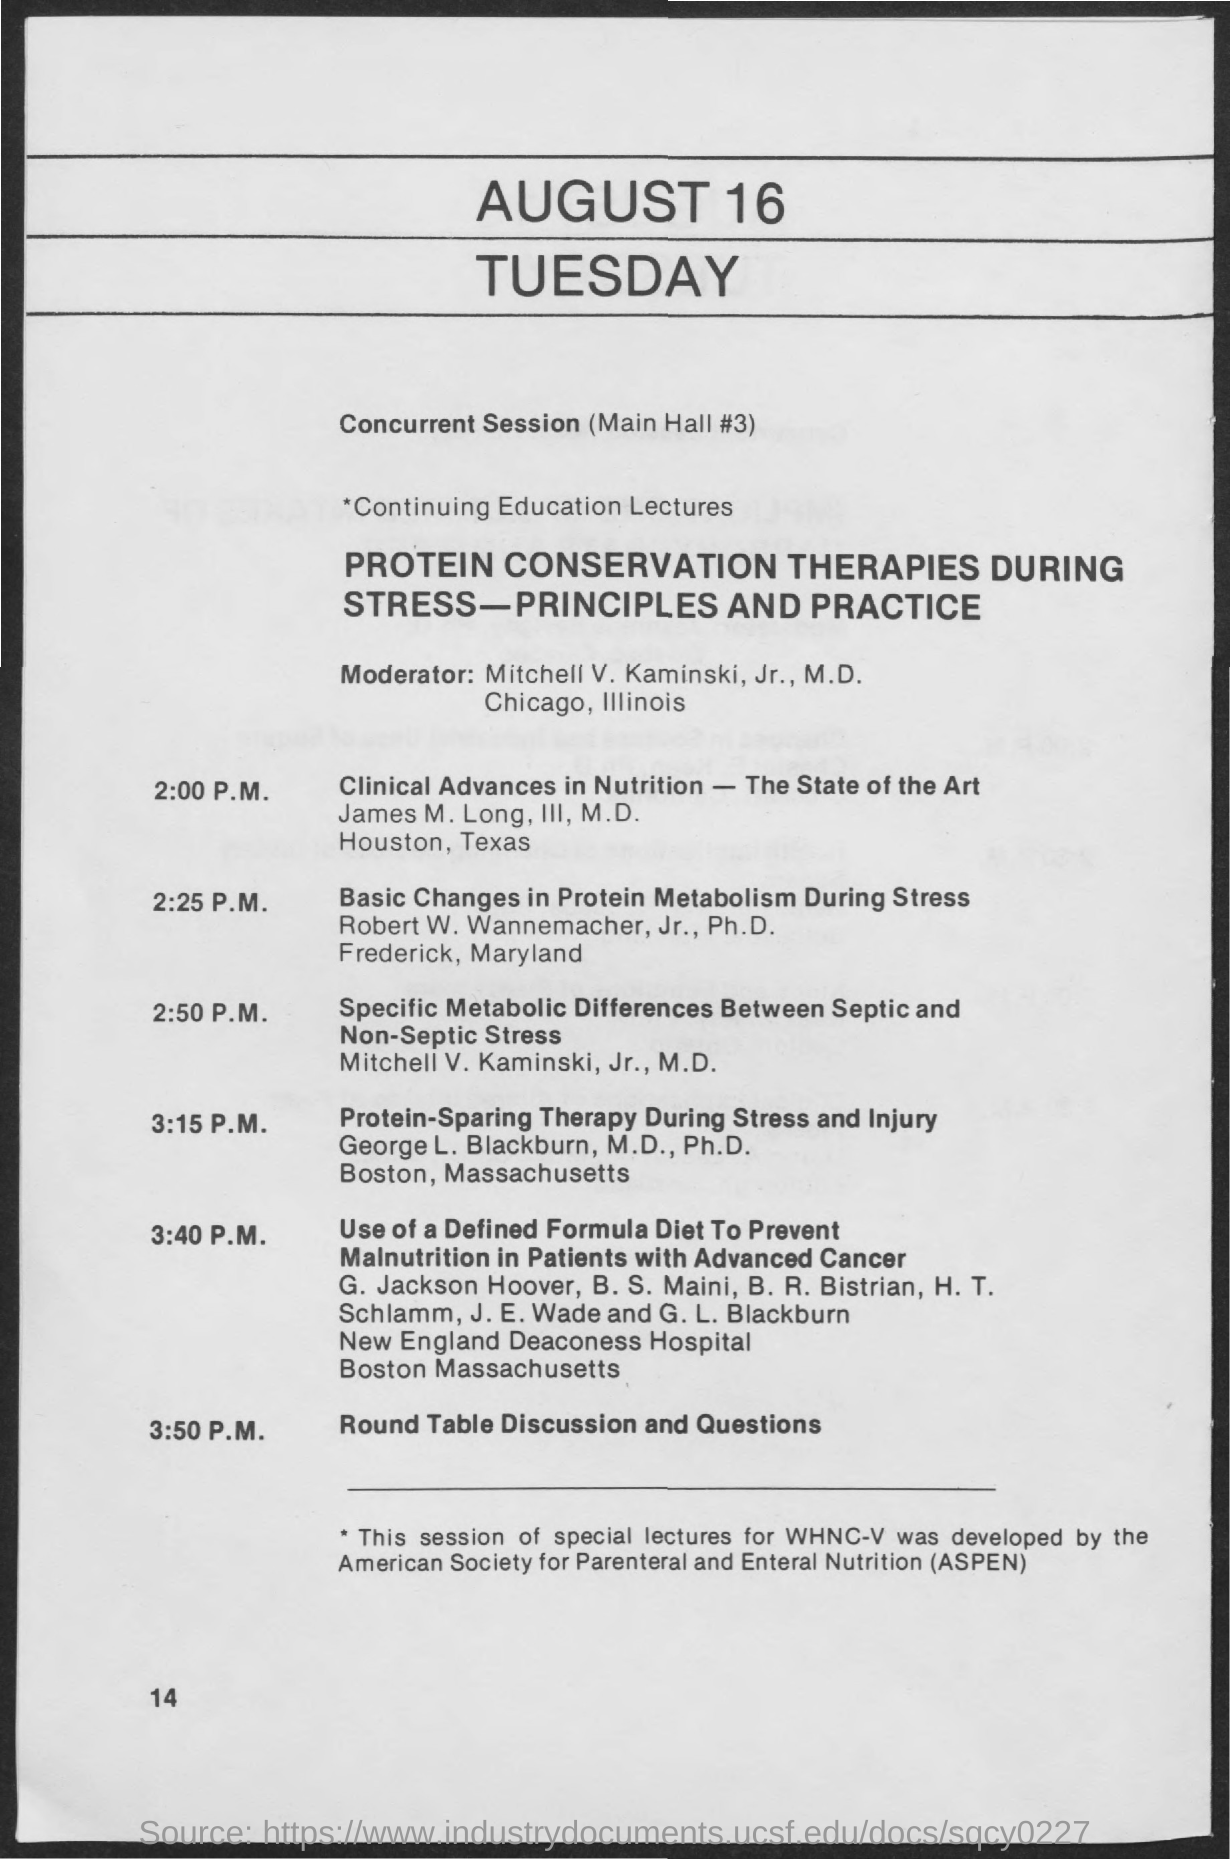Where is the concurrent session?
Provide a short and direct response. (Main Hall #3). What is the lecture on?
Your answer should be compact. PROTEIN CONSERVATION THERAPIES DURING STRESS -PRINCIPLES AND PRACTICE. Who is the moderator?
Provide a succinct answer. Mitchell V. Kaminski, Jr., M.D. What is the lecture at 3:15 P.M.?
Your answer should be very brief. Protein-sparing therapy during stress and injury. At what time is the Round Table Discussion and Questions?
Your response must be concise. 3:50 P.M. Who is taking the lecture on Clinical Advances in Nutrition - The State of the Art?
Your response must be concise. James M. Long, III, M.D. What does ASPEN stand for?
Keep it short and to the point. American society for parenteral and enteral nutrition. What is the lecture of Robert W. Wannemacher?
Provide a succinct answer. Basic Changes in Protein Metabolism During Stress. 